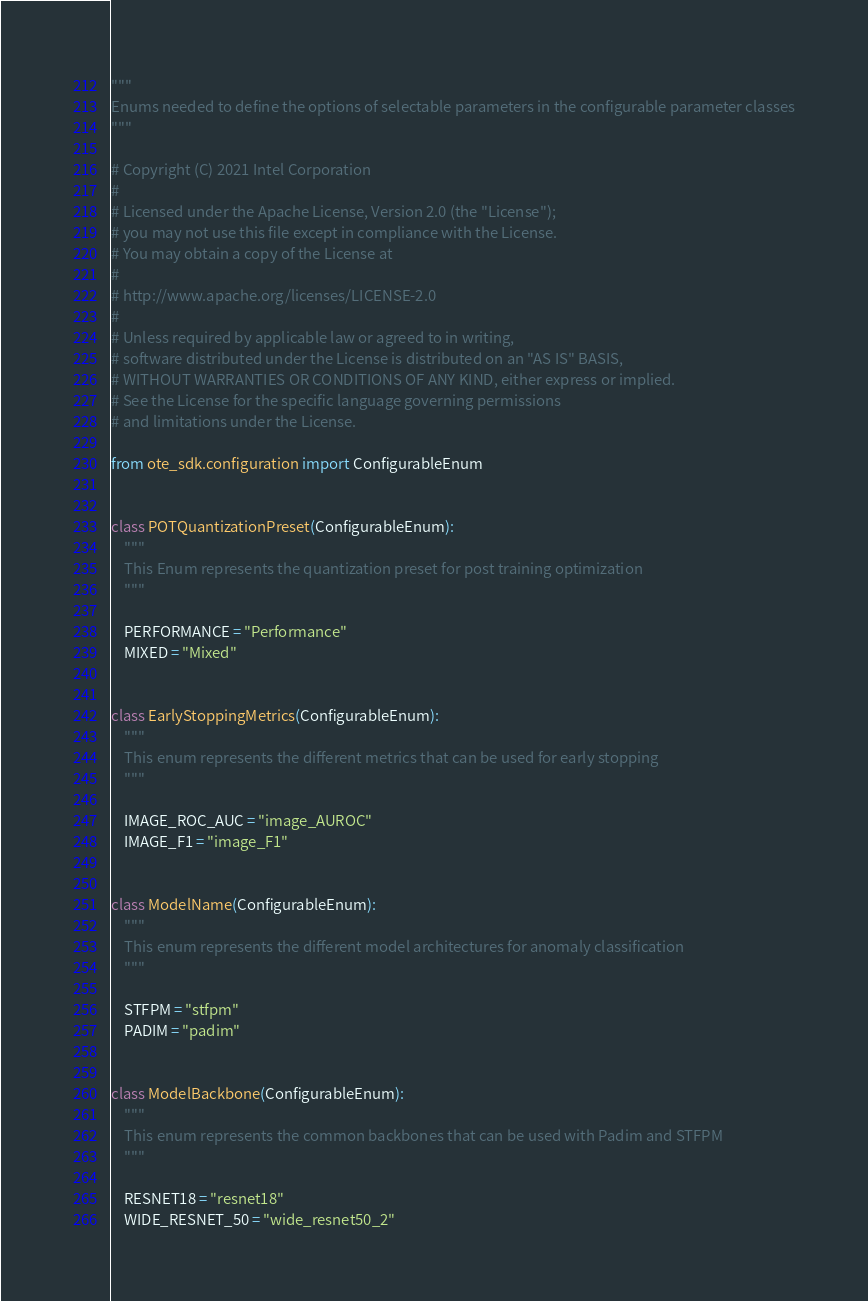Convert code to text. <code><loc_0><loc_0><loc_500><loc_500><_Python_>"""
Enums needed to define the options of selectable parameters in the configurable parameter classes
"""

# Copyright (C) 2021 Intel Corporation
#
# Licensed under the Apache License, Version 2.0 (the "License");
# you may not use this file except in compliance with the License.
# You may obtain a copy of the License at
#
# http://www.apache.org/licenses/LICENSE-2.0
#
# Unless required by applicable law or agreed to in writing,
# software distributed under the License is distributed on an "AS IS" BASIS,
# WITHOUT WARRANTIES OR CONDITIONS OF ANY KIND, either express or implied.
# See the License for the specific language governing permissions
# and limitations under the License.

from ote_sdk.configuration import ConfigurableEnum


class POTQuantizationPreset(ConfigurableEnum):
    """
    This Enum represents the quantization preset for post training optimization
    """

    PERFORMANCE = "Performance"
    MIXED = "Mixed"


class EarlyStoppingMetrics(ConfigurableEnum):
    """
    This enum represents the different metrics that can be used for early stopping
    """

    IMAGE_ROC_AUC = "image_AUROC"
    IMAGE_F1 = "image_F1"


class ModelName(ConfigurableEnum):
    """
    This enum represents the different model architectures for anomaly classification
    """

    STFPM = "stfpm"
    PADIM = "padim"


class ModelBackbone(ConfigurableEnum):
    """
    This enum represents the common backbones that can be used with Padim and STFPM
    """

    RESNET18 = "resnet18"
    WIDE_RESNET_50 = "wide_resnet50_2"
</code> 